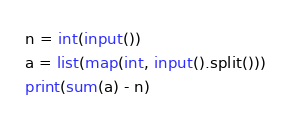<code> <loc_0><loc_0><loc_500><loc_500><_Python_>n = int(input())
a = list(map(int, input().split()))
print(sum(a) - n)
</code> 